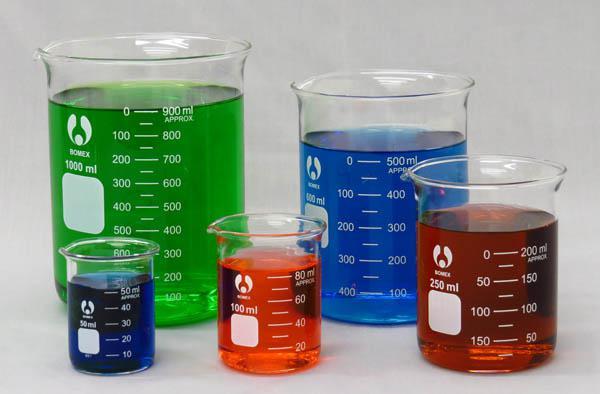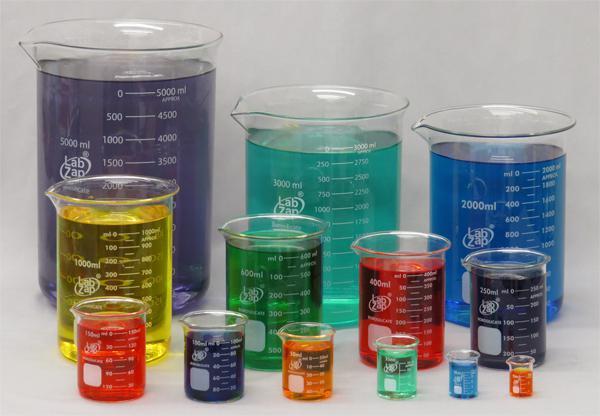The first image is the image on the left, the second image is the image on the right. Considering the images on both sides, is "There is no less than 14 filled beakers." valid? Answer yes or no. Yes. The first image is the image on the left, the second image is the image on the right. Analyze the images presented: Is the assertion "There is green liquid in both images." valid? Answer yes or no. Yes. 